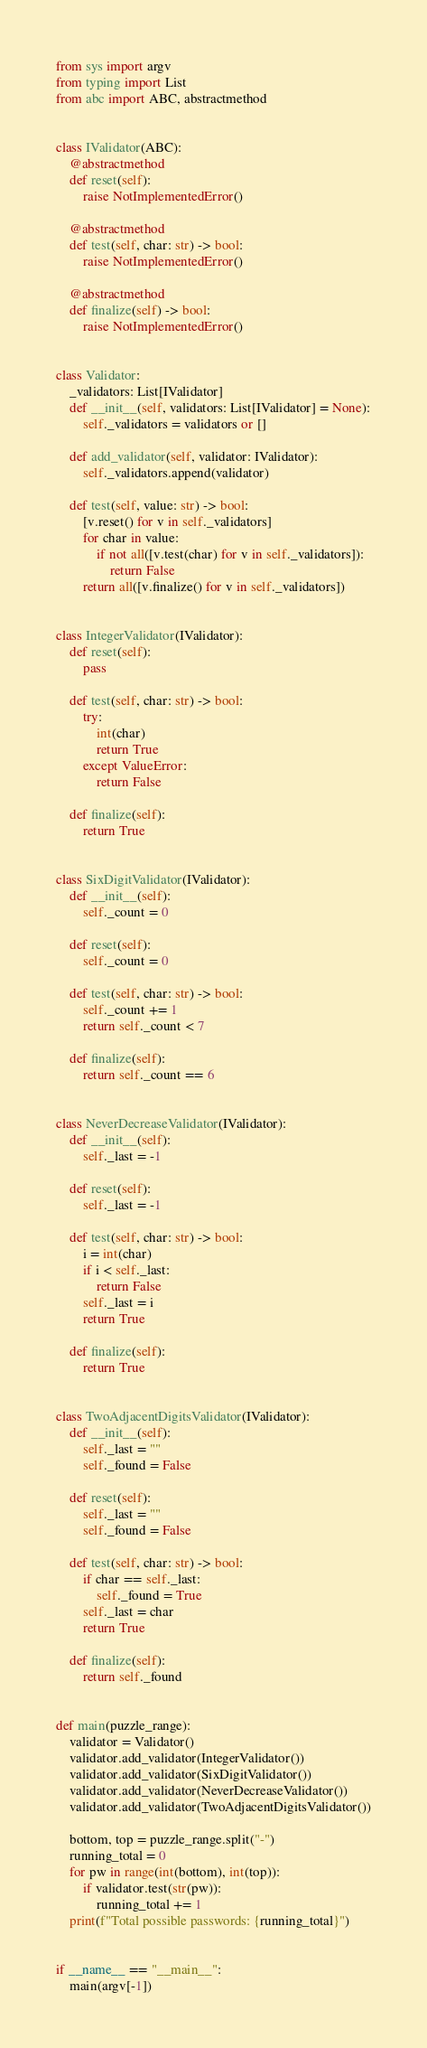Convert code to text. <code><loc_0><loc_0><loc_500><loc_500><_Python_>from sys import argv
from typing import List
from abc import ABC, abstractmethod


class IValidator(ABC):
    @abstractmethod
    def reset(self):
        raise NotImplementedError()

    @abstractmethod
    def test(self, char: str) -> bool:
        raise NotImplementedError()

    @abstractmethod
    def finalize(self) -> bool:
        raise NotImplementedError()


class Validator:
    _validators: List[IValidator]
    def __init__(self, validators: List[IValidator] = None):
        self._validators = validators or []

    def add_validator(self, validator: IValidator):
        self._validators.append(validator)

    def test(self, value: str) -> bool:
        [v.reset() for v in self._validators]
        for char in value:
            if not all([v.test(char) for v in self._validators]):
                return False
        return all([v.finalize() for v in self._validators])


class IntegerValidator(IValidator):
    def reset(self):
        pass

    def test(self, char: str) -> bool:
        try:
            int(char)
            return True
        except ValueError:
            return False

    def finalize(self):
        return True


class SixDigitValidator(IValidator):
    def __init__(self):
        self._count = 0

    def reset(self):
        self._count = 0

    def test(self, char: str) -> bool:
        self._count += 1
        return self._count < 7

    def finalize(self):
        return self._count == 6


class NeverDecreaseValidator(IValidator):
    def __init__(self):
        self._last = -1

    def reset(self):
        self._last = -1

    def test(self, char: str) -> bool:
        i = int(char)
        if i < self._last:
            return False
        self._last = i
        return True

    def finalize(self):
        return True


class TwoAdjacentDigitsValidator(IValidator):
    def __init__(self):
        self._last = ""
        self._found = False

    def reset(self):
        self._last = ""
        self._found = False

    def test(self, char: str) -> bool:
        if char == self._last:
            self._found = True
        self._last = char
        return True

    def finalize(self):
        return self._found


def main(puzzle_range):
    validator = Validator()
    validator.add_validator(IntegerValidator())
    validator.add_validator(SixDigitValidator())
    validator.add_validator(NeverDecreaseValidator())
    validator.add_validator(TwoAdjacentDigitsValidator())

    bottom, top = puzzle_range.split("-")
    running_total = 0
    for pw in range(int(bottom), int(top)):
        if validator.test(str(pw)):
            running_total += 1
    print(f"Total possible passwords: {running_total}")


if __name__ == "__main__":
    main(argv[-1])
</code> 